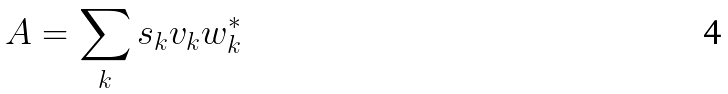<formula> <loc_0><loc_0><loc_500><loc_500>A = \sum _ { k } s _ { k } v _ { k } w _ { k } ^ { * }</formula> 